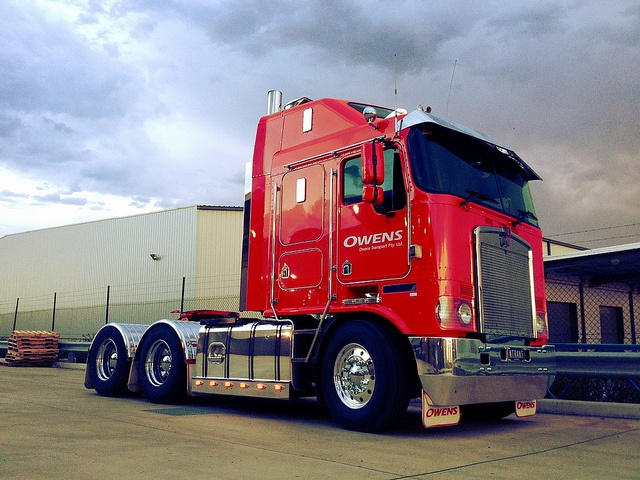Describe the objects in this image and their specific colors. I can see a truck in lightblue, black, brown, navy, and gray tones in this image. 